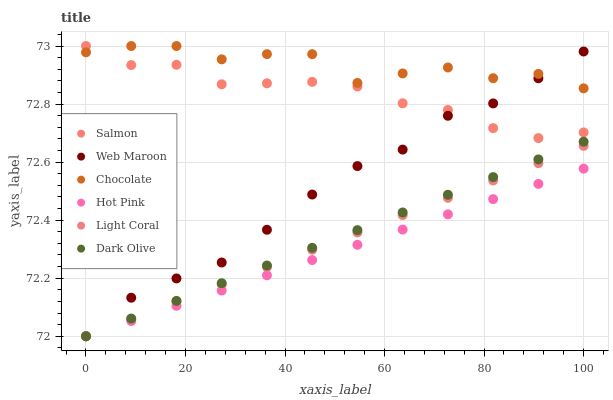Does Hot Pink have the minimum area under the curve?
Answer yes or no. Yes. Does Chocolate have the maximum area under the curve?
Answer yes or no. Yes. Does Salmon have the minimum area under the curve?
Answer yes or no. No. Does Salmon have the maximum area under the curve?
Answer yes or no. No. Is Hot Pink the smoothest?
Answer yes or no. Yes. Is Chocolate the roughest?
Answer yes or no. Yes. Is Salmon the smoothest?
Answer yes or no. No. Is Salmon the roughest?
Answer yes or no. No. Does Hot Pink have the lowest value?
Answer yes or no. Yes. Does Salmon have the lowest value?
Answer yes or no. No. Does Chocolate have the highest value?
Answer yes or no. Yes. Does Dark Olive have the highest value?
Answer yes or no. No. Is Dark Olive less than Salmon?
Answer yes or no. Yes. Is Chocolate greater than Hot Pink?
Answer yes or no. Yes. Does Web Maroon intersect Light Coral?
Answer yes or no. Yes. Is Web Maroon less than Light Coral?
Answer yes or no. No. Is Web Maroon greater than Light Coral?
Answer yes or no. No. Does Dark Olive intersect Salmon?
Answer yes or no. No. 